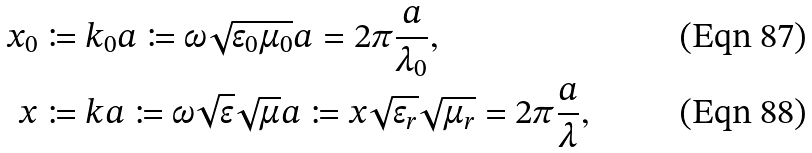Convert formula to latex. <formula><loc_0><loc_0><loc_500><loc_500>x _ { 0 } & \coloneqq k _ { 0 } a \coloneqq \omega \sqrt { \epsilon _ { 0 } \mu _ { 0 } } a = 2 \pi \frac { a } { \lambda _ { 0 } } , \\ x & \coloneqq k a \coloneqq \omega \sqrt { \epsilon } \sqrt { \mu } a \coloneqq x \sqrt { \epsilon _ { r } } \sqrt { \mu _ { r } } = 2 \pi \frac { a } { \lambda } ,</formula> 